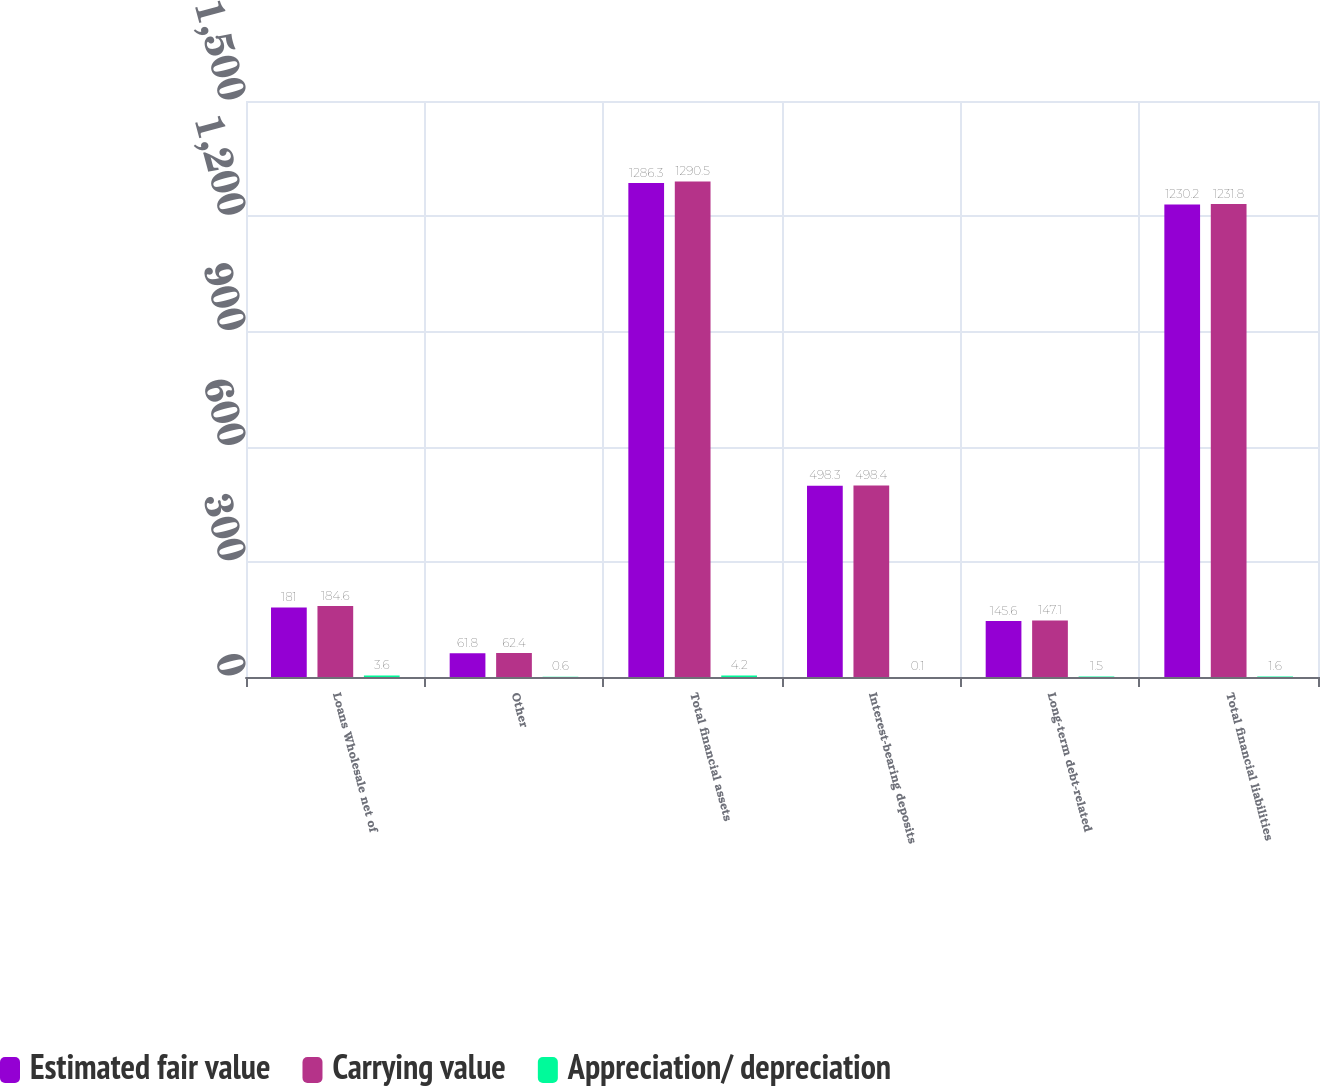Convert chart to OTSL. <chart><loc_0><loc_0><loc_500><loc_500><stacked_bar_chart><ecel><fcel>Loans Wholesale net of<fcel>Other<fcel>Total financial assets<fcel>Interest-bearing deposits<fcel>Long-term debt-related<fcel>Total financial liabilities<nl><fcel>Estimated fair value<fcel>181<fcel>61.8<fcel>1286.3<fcel>498.3<fcel>145.6<fcel>1230.2<nl><fcel>Carrying value<fcel>184.6<fcel>62.4<fcel>1290.5<fcel>498.4<fcel>147.1<fcel>1231.8<nl><fcel>Appreciation/ depreciation<fcel>3.6<fcel>0.6<fcel>4.2<fcel>0.1<fcel>1.5<fcel>1.6<nl></chart> 